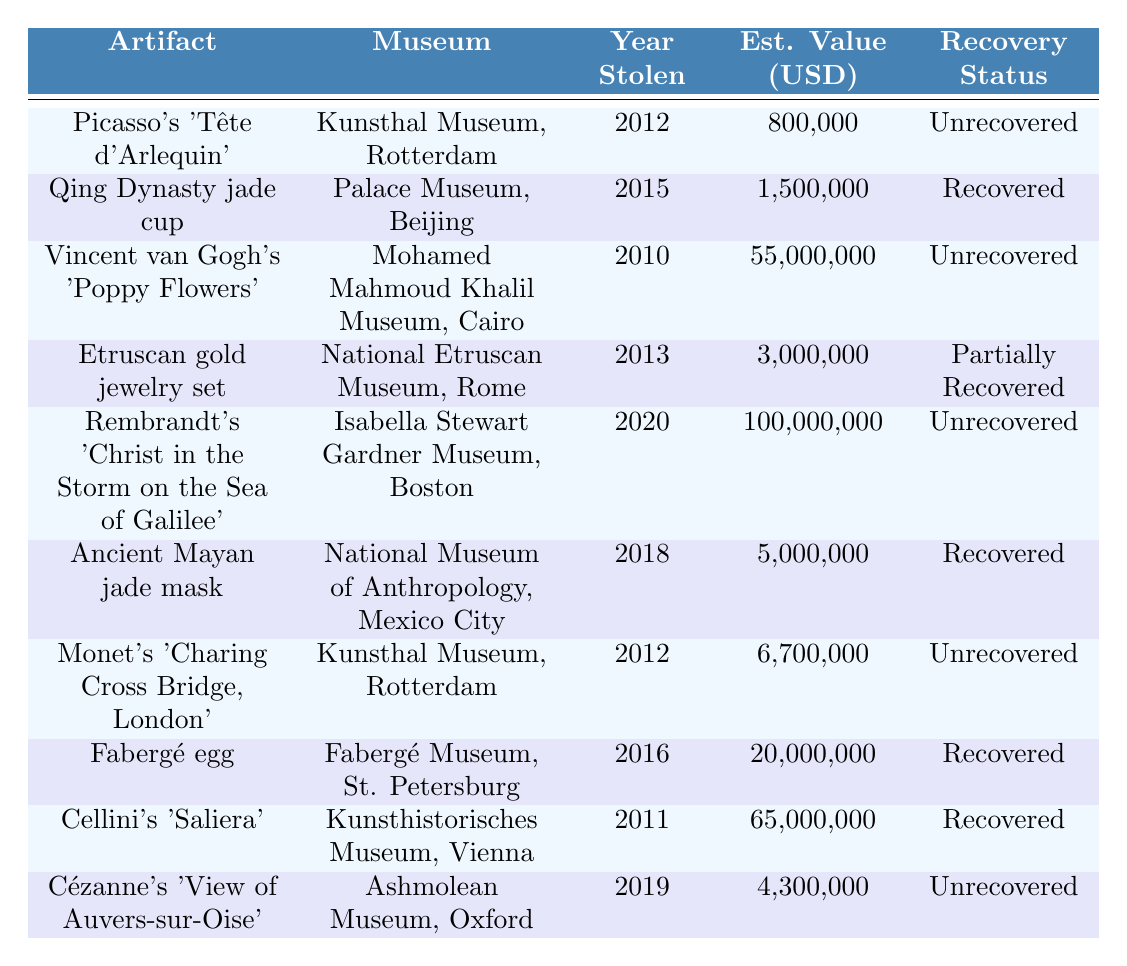What artifact was stolen in 2015? According to the table, the Qing Dynasty jade cup was stolen in 2015.
Answer: Qing Dynasty jade cup How many artifacts have been recovered? From the table, the recovered artifacts are the Qing Dynasty jade cup, Ancient Mayan jade mask, Fabergé egg, and Cellini's 'Saliera'. Counting these gives 4 recovered artifacts.
Answer: 4 What is the estimated value of Rembrandt's stolen artwork? The table shows that Rembrandt's 'Christ in the Storm on the Sea of Galilee', stolen in 2020, has an estimated value of 100,000,000 USD.
Answer: 100,000,000 USD Which artifact has the highest estimated value? By examining the table, Rembrandt's 'Christ in the Storm on the Sea of Galilee' is listed with the highest estimated value of 100,000,000 USD.
Answer: Rembrandt's 'Christ in the Storm on the Sea of Galilee' Was the Cellini's 'Saliera' recovered? The table indicates that Cellini's 'Saliera' was marked as recovered.
Answer: Yes How much more valuable was Vincent van Gogh's 'Poppy Flowers' than Monet's 'Charing Cross Bridge'? The estimated value of Vincent van Gogh's 'Poppy Flowers' is 55,000,000 USD, and Monet's 'Charing Cross Bridge' is valued at 6,700,000 USD. The difference is 55,000,000 - 6,700,000 = 48,300,000 USD.
Answer: 48,300,000 USD List the years when artifacts were stolen from the Kunsthal Museum. The table shows two artifacts stolen from the Kunsthal Museum: Picasso's 'Tête d'Arlequin' in 2012 and Monet's 'Charing Cross Bridge, London' in 2012. Both were stolen that same year.
Answer: 2012 Is there an unrecovered artifact from the National Etruscan Museum, Rome? According to the table, the Etruscan gold jewelry set was partially recovered, so it is not completely unrecovered. However, it indicates the museum had other issues. Thus it is false to say the artifact is unrecovered.
Answer: No What is the average estimated value of the unrecovered artifacts listed in the table? The unrecovered artifacts are Picasso's 'Tête d'Arlequin' (800,000), Vincent van Gogh's 'Poppy Flowers' (55,000,000), Rembrandt's 'Christ in the Storm' (100,000,000), and Monet's 'Charing Cross Bridge' (6,700,000). Their total value is 800,000 + 55,000,000 + 100,000,000 + 6,700,000 = 162,500,000. There are 4 artifacts, so the average is 162,500,000 / 4 = 40,625,000.
Answer: 40,625,000 How many artifacts were stolen before 2015? Evaluating the table, the stolen artifacts before 2015 are Picasso's 'Tête d'Arlequin' (2012), and Vincent van Gogh's 'Poppy Flowers' (2010). This gives us a total of 2 artifacts.
Answer: 2 